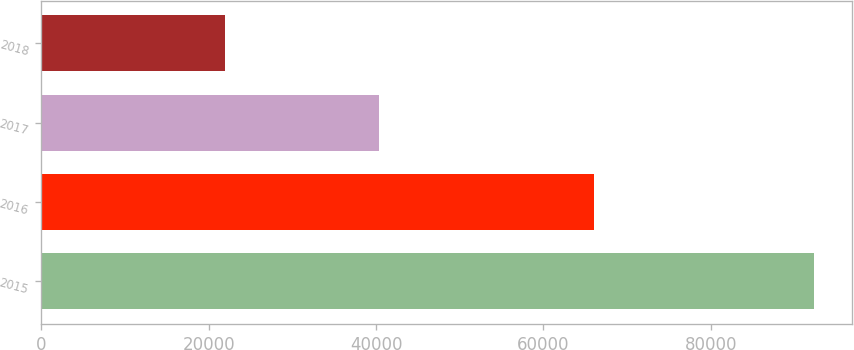Convert chart to OTSL. <chart><loc_0><loc_0><loc_500><loc_500><bar_chart><fcel>2015<fcel>2016<fcel>2017<fcel>2018<nl><fcel>92333<fcel>66083<fcel>40357<fcel>21936<nl></chart> 